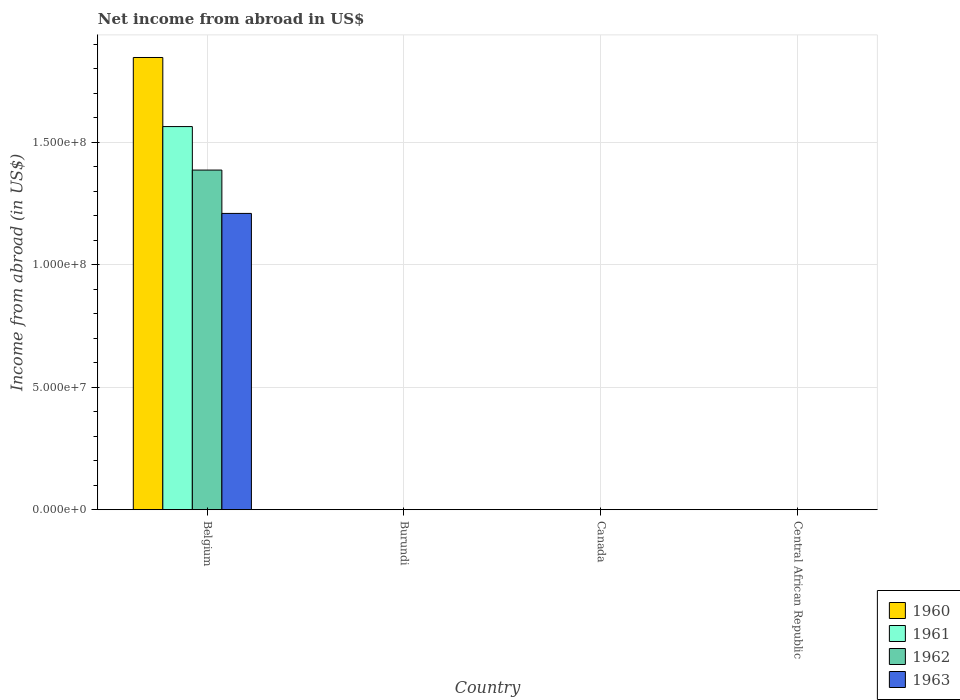How many different coloured bars are there?
Offer a very short reply. 4. Are the number of bars per tick equal to the number of legend labels?
Make the answer very short. No. Are the number of bars on each tick of the X-axis equal?
Provide a succinct answer. No. What is the label of the 3rd group of bars from the left?
Ensure brevity in your answer.  Canada. In how many cases, is the number of bars for a given country not equal to the number of legend labels?
Offer a very short reply. 3. What is the net income from abroad in 1960 in Canada?
Offer a very short reply. 0. Across all countries, what is the maximum net income from abroad in 1962?
Offer a terse response. 1.39e+08. Across all countries, what is the minimum net income from abroad in 1961?
Give a very brief answer. 0. In which country was the net income from abroad in 1960 maximum?
Your answer should be very brief. Belgium. What is the total net income from abroad in 1963 in the graph?
Your response must be concise. 1.21e+08. What is the difference between the net income from abroad in 1963 in Belgium and the net income from abroad in 1961 in Canada?
Provide a short and direct response. 1.21e+08. What is the average net income from abroad in 1962 per country?
Give a very brief answer. 3.47e+07. What is the difference between the net income from abroad of/in 1960 and net income from abroad of/in 1963 in Belgium?
Offer a terse response. 6.37e+07. In how many countries, is the net income from abroad in 1962 greater than 90000000 US$?
Give a very brief answer. 1. What is the difference between the highest and the lowest net income from abroad in 1960?
Your response must be concise. 1.85e+08. In how many countries, is the net income from abroad in 1960 greater than the average net income from abroad in 1960 taken over all countries?
Give a very brief answer. 1. How many bars are there?
Your answer should be compact. 4. Are all the bars in the graph horizontal?
Keep it short and to the point. No. Are the values on the major ticks of Y-axis written in scientific E-notation?
Provide a short and direct response. Yes. Does the graph contain any zero values?
Make the answer very short. Yes. How many legend labels are there?
Give a very brief answer. 4. How are the legend labels stacked?
Your answer should be compact. Vertical. What is the title of the graph?
Provide a succinct answer. Net income from abroad in US$. What is the label or title of the X-axis?
Your answer should be very brief. Country. What is the label or title of the Y-axis?
Offer a very short reply. Income from abroad (in US$). What is the Income from abroad (in US$) of 1960 in Belgium?
Provide a succinct answer. 1.85e+08. What is the Income from abroad (in US$) of 1961 in Belgium?
Provide a short and direct response. 1.56e+08. What is the Income from abroad (in US$) of 1962 in Belgium?
Provide a short and direct response. 1.39e+08. What is the Income from abroad (in US$) in 1963 in Belgium?
Give a very brief answer. 1.21e+08. What is the Income from abroad (in US$) in 1960 in Burundi?
Offer a terse response. 0. What is the Income from abroad (in US$) of 1961 in Burundi?
Keep it short and to the point. 0. What is the Income from abroad (in US$) of 1962 in Burundi?
Your answer should be very brief. 0. What is the Income from abroad (in US$) in 1960 in Canada?
Keep it short and to the point. 0. What is the Income from abroad (in US$) in 1960 in Central African Republic?
Give a very brief answer. 0. What is the Income from abroad (in US$) in 1961 in Central African Republic?
Make the answer very short. 0. What is the Income from abroad (in US$) in 1962 in Central African Republic?
Your answer should be compact. 0. Across all countries, what is the maximum Income from abroad (in US$) in 1960?
Make the answer very short. 1.85e+08. Across all countries, what is the maximum Income from abroad (in US$) in 1961?
Ensure brevity in your answer.  1.56e+08. Across all countries, what is the maximum Income from abroad (in US$) of 1962?
Keep it short and to the point. 1.39e+08. Across all countries, what is the maximum Income from abroad (in US$) in 1963?
Keep it short and to the point. 1.21e+08. Across all countries, what is the minimum Income from abroad (in US$) in 1960?
Keep it short and to the point. 0. Across all countries, what is the minimum Income from abroad (in US$) of 1961?
Offer a very short reply. 0. What is the total Income from abroad (in US$) of 1960 in the graph?
Offer a very short reply. 1.85e+08. What is the total Income from abroad (in US$) of 1961 in the graph?
Keep it short and to the point. 1.56e+08. What is the total Income from abroad (in US$) in 1962 in the graph?
Give a very brief answer. 1.39e+08. What is the total Income from abroad (in US$) in 1963 in the graph?
Your response must be concise. 1.21e+08. What is the average Income from abroad (in US$) of 1960 per country?
Offer a terse response. 4.61e+07. What is the average Income from abroad (in US$) of 1961 per country?
Offer a terse response. 3.91e+07. What is the average Income from abroad (in US$) of 1962 per country?
Your response must be concise. 3.47e+07. What is the average Income from abroad (in US$) of 1963 per country?
Offer a terse response. 3.02e+07. What is the difference between the Income from abroad (in US$) in 1960 and Income from abroad (in US$) in 1961 in Belgium?
Provide a succinct answer. 2.82e+07. What is the difference between the Income from abroad (in US$) of 1960 and Income from abroad (in US$) of 1962 in Belgium?
Provide a succinct answer. 4.60e+07. What is the difference between the Income from abroad (in US$) of 1960 and Income from abroad (in US$) of 1963 in Belgium?
Ensure brevity in your answer.  6.37e+07. What is the difference between the Income from abroad (in US$) of 1961 and Income from abroad (in US$) of 1962 in Belgium?
Your answer should be very brief. 1.78e+07. What is the difference between the Income from abroad (in US$) of 1961 and Income from abroad (in US$) of 1963 in Belgium?
Your answer should be very brief. 3.55e+07. What is the difference between the Income from abroad (in US$) in 1962 and Income from abroad (in US$) in 1963 in Belgium?
Offer a very short reply. 1.77e+07. What is the difference between the highest and the lowest Income from abroad (in US$) of 1960?
Make the answer very short. 1.85e+08. What is the difference between the highest and the lowest Income from abroad (in US$) in 1961?
Provide a short and direct response. 1.56e+08. What is the difference between the highest and the lowest Income from abroad (in US$) of 1962?
Provide a short and direct response. 1.39e+08. What is the difference between the highest and the lowest Income from abroad (in US$) of 1963?
Ensure brevity in your answer.  1.21e+08. 